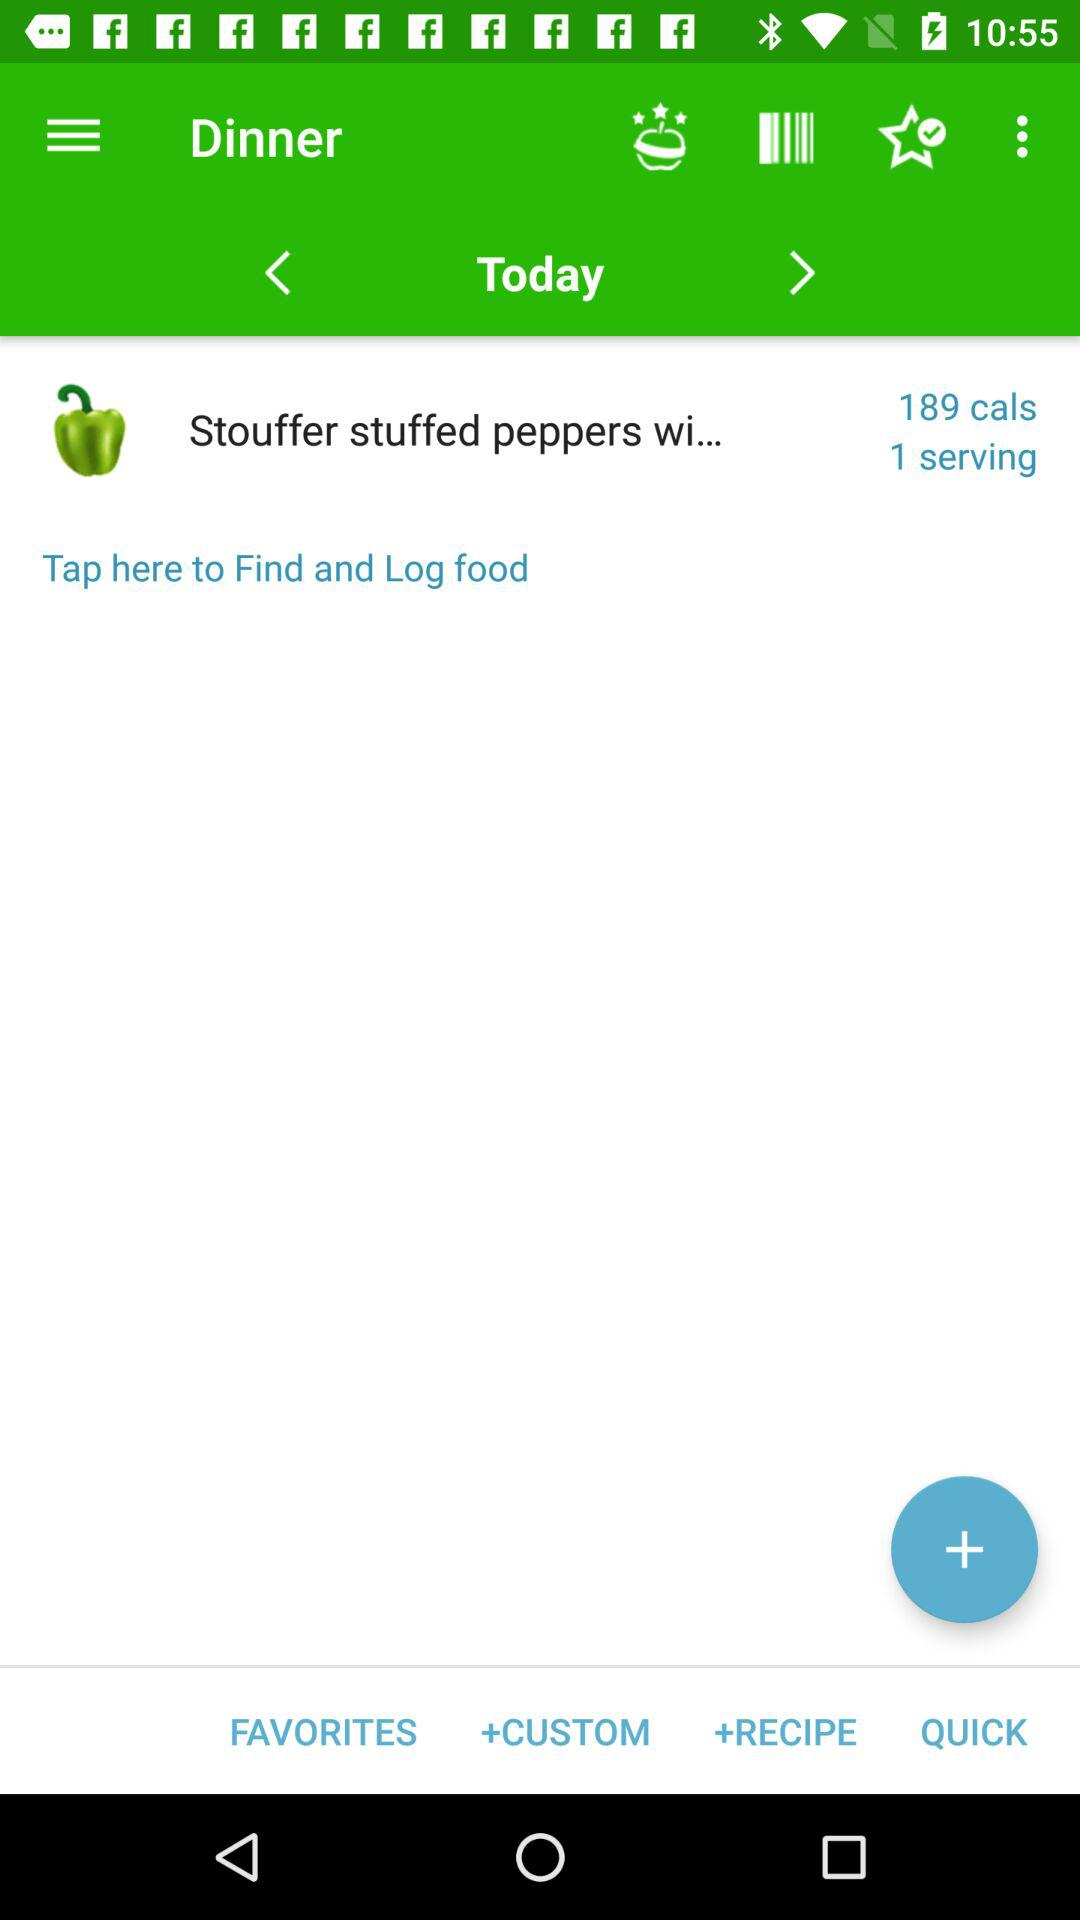Which day is selected? The selected day is Today. 